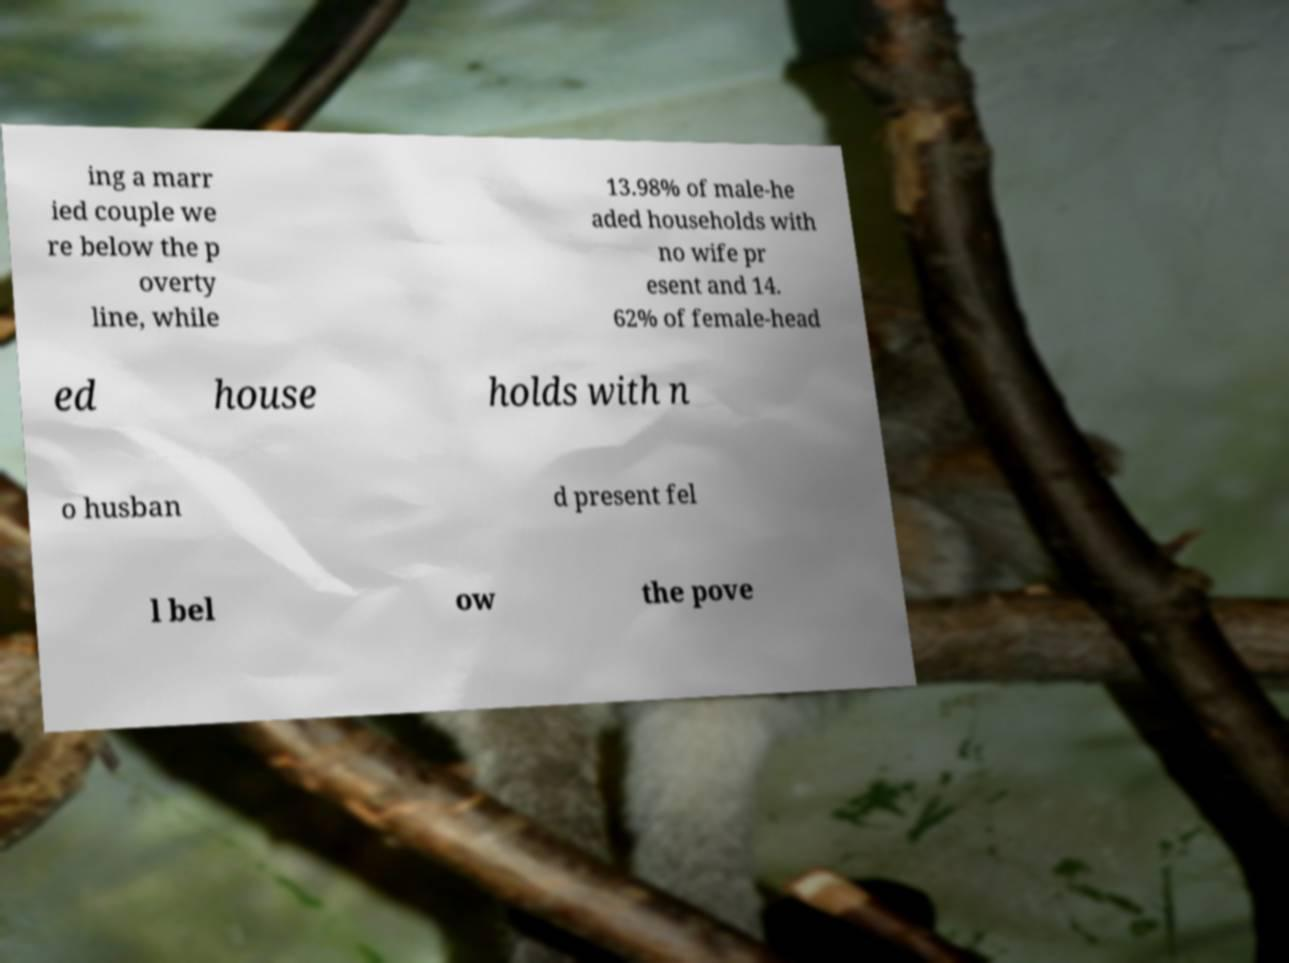There's text embedded in this image that I need extracted. Can you transcribe it verbatim? ing a marr ied couple we re below the p overty line, while 13.98% of male-he aded households with no wife pr esent and 14. 62% of female-head ed house holds with n o husban d present fel l bel ow the pove 